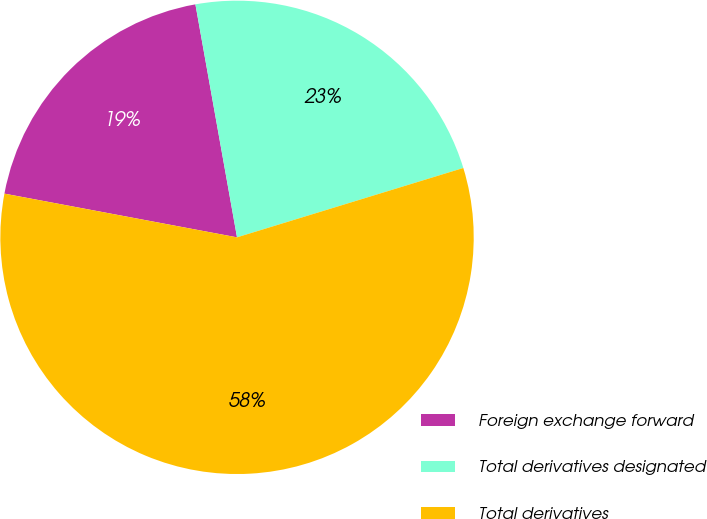Convert chart to OTSL. <chart><loc_0><loc_0><loc_500><loc_500><pie_chart><fcel>Foreign exchange forward<fcel>Total derivatives designated<fcel>Total derivatives<nl><fcel>19.23%<fcel>23.08%<fcel>57.69%<nl></chart> 